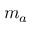Convert formula to latex. <formula><loc_0><loc_0><loc_500><loc_500>m _ { a }</formula> 